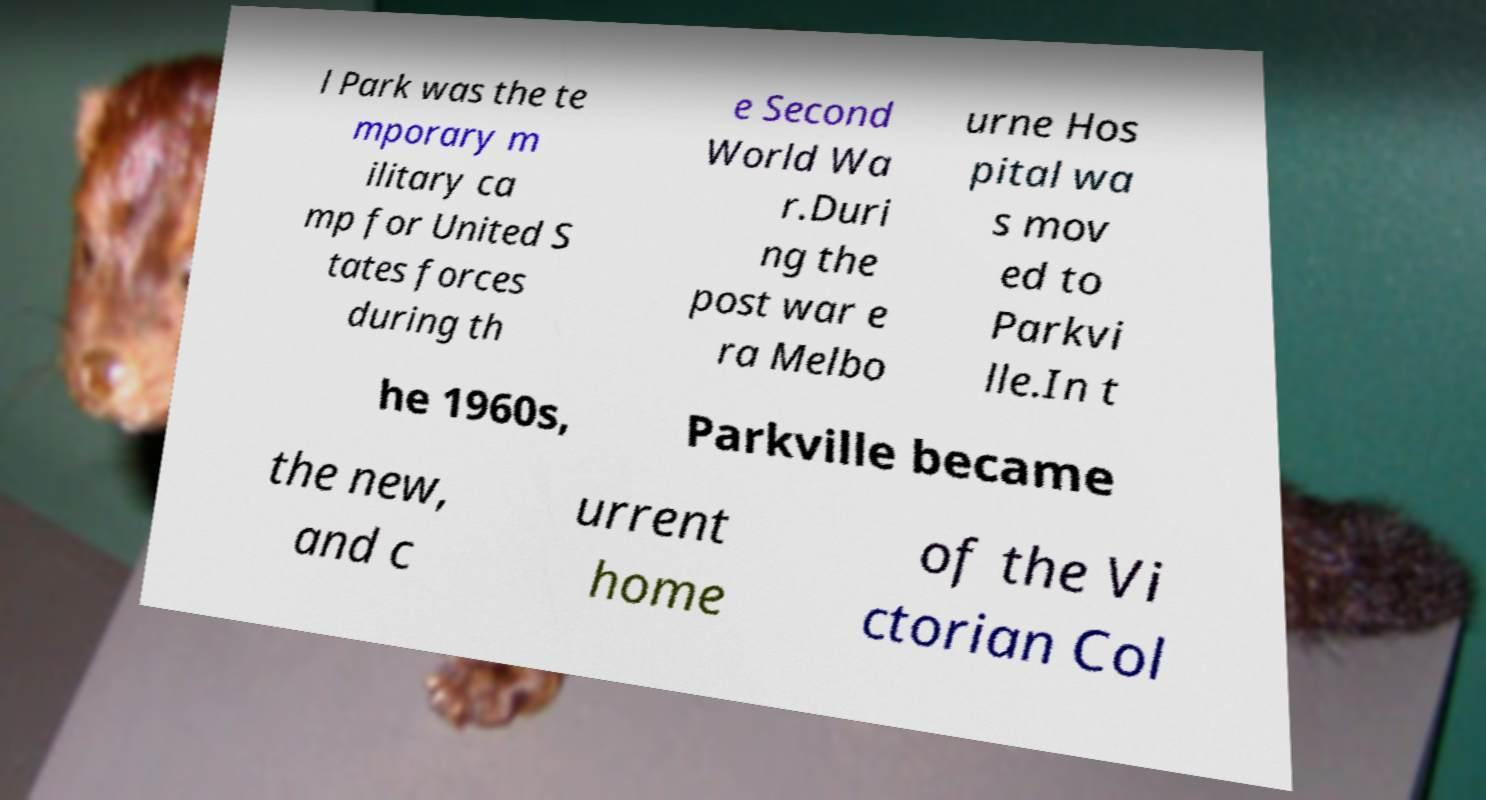Could you extract and type out the text from this image? l Park was the te mporary m ilitary ca mp for United S tates forces during th e Second World Wa r.Duri ng the post war e ra Melbo urne Hos pital wa s mov ed to Parkvi lle.In t he 1960s, Parkville became the new, and c urrent home of the Vi ctorian Col 